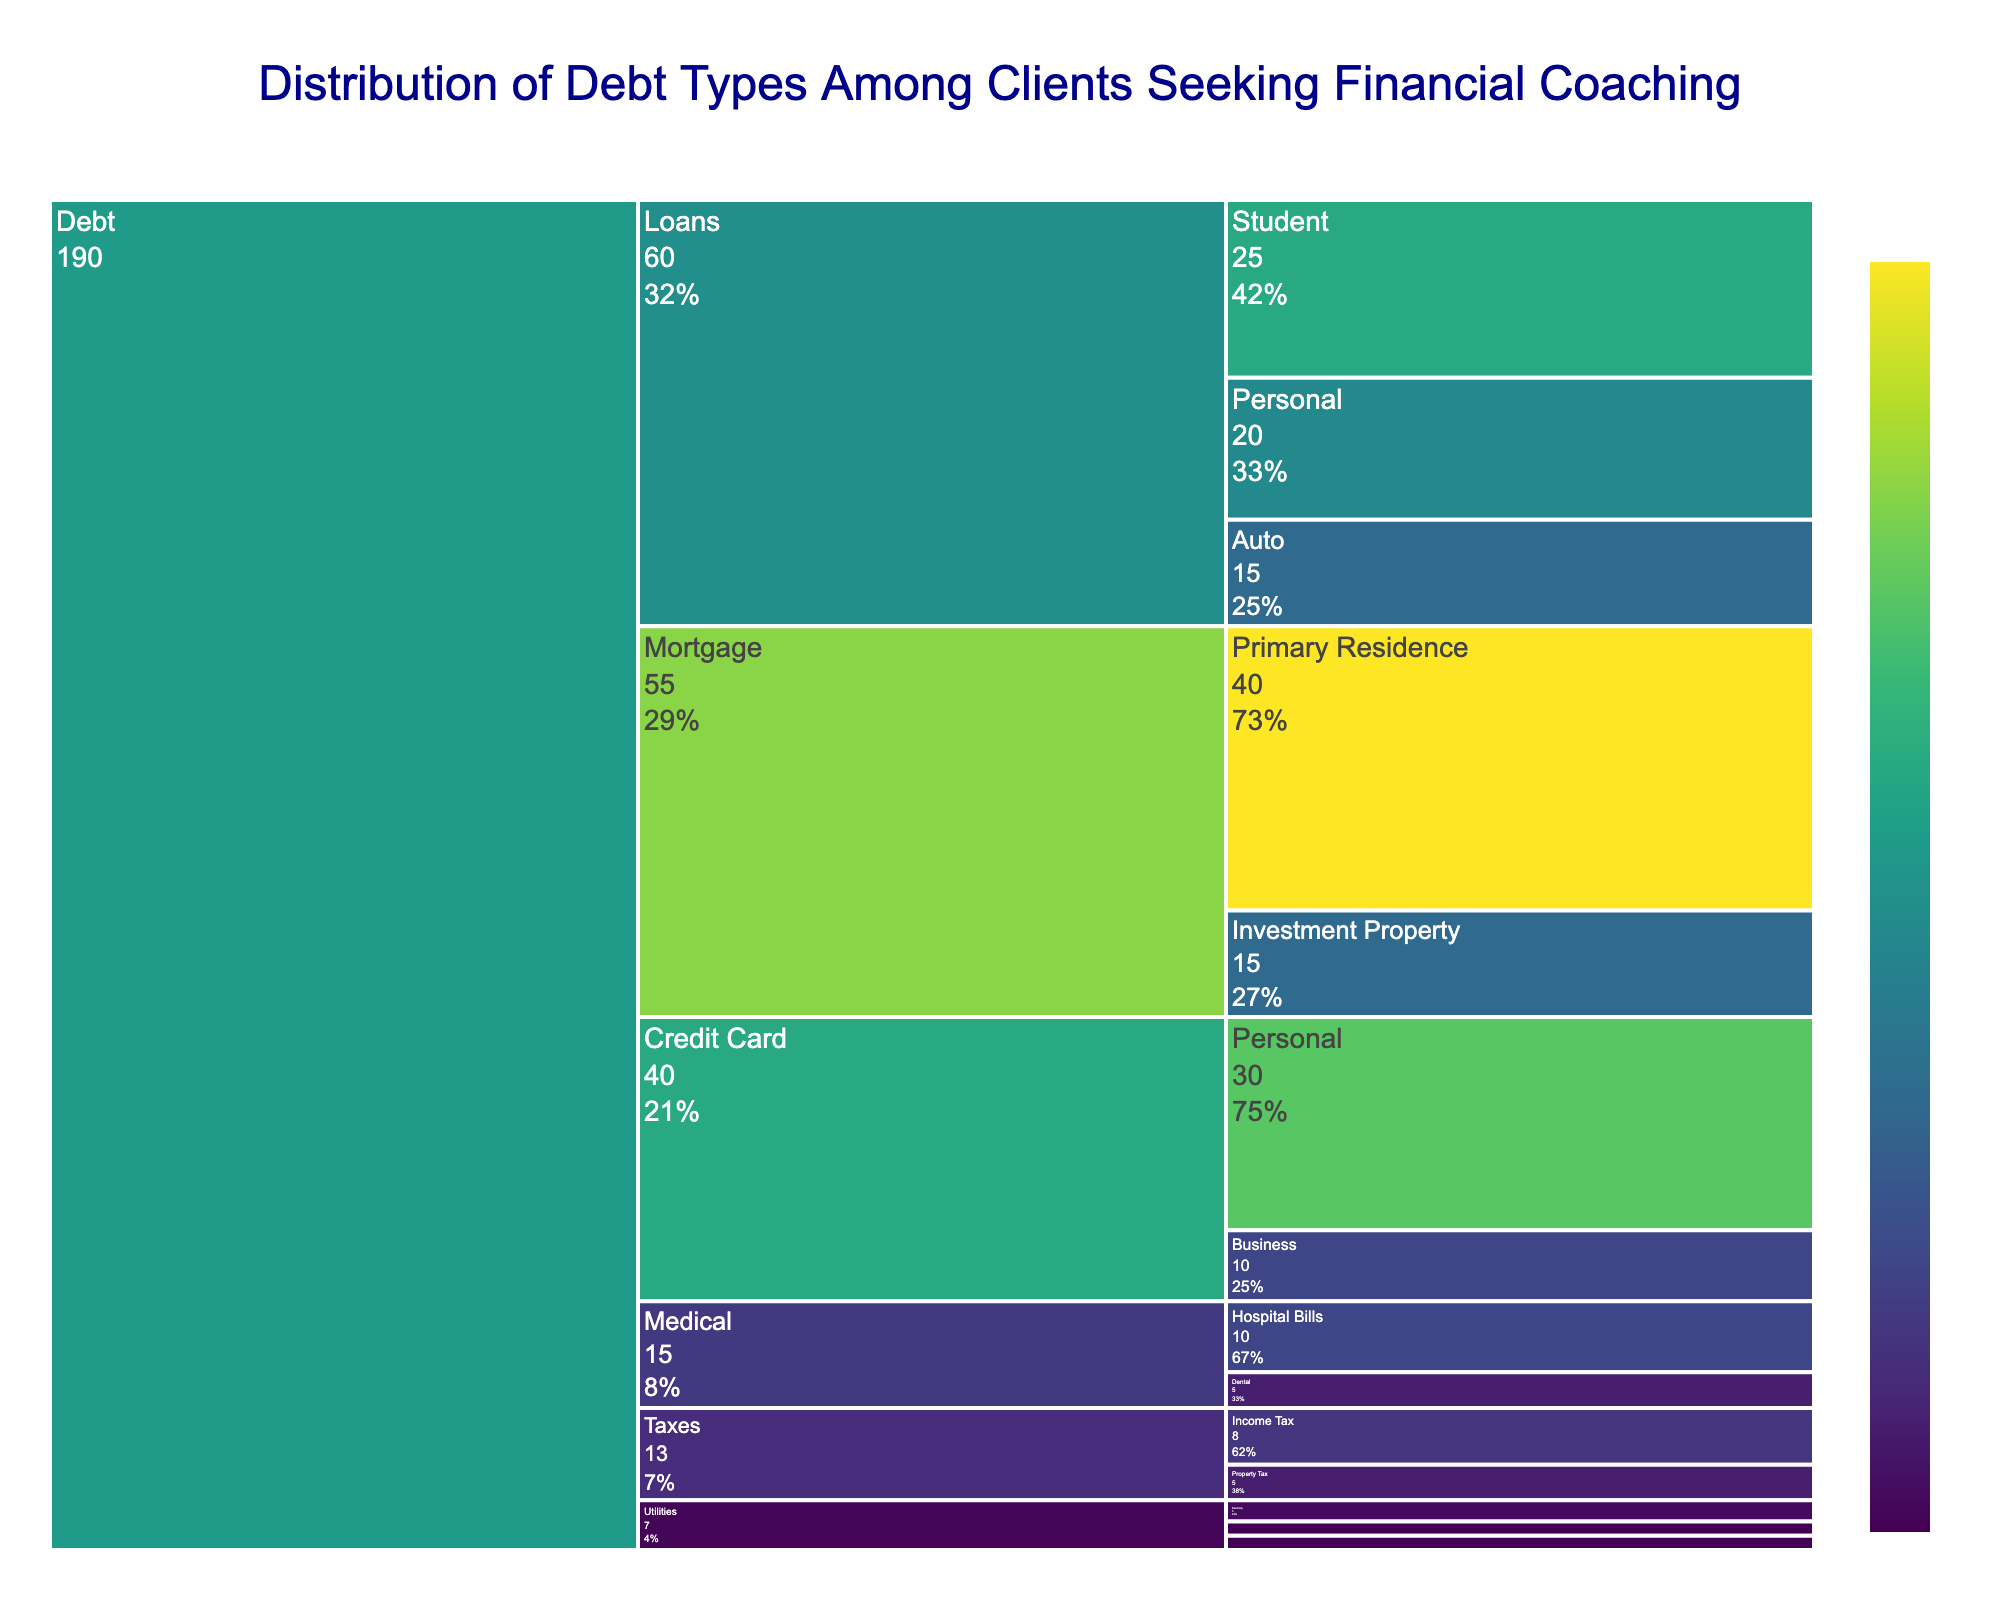What is the title of the icicle chart? The title of the chart is located at the top and usually describes what the chart is about.
Answer: Distribution of Debt Types Among Clients Seeking Financial Coaching Which subtype has the highest value under the 'Mortgage' category? Locate the 'Mortgage' category in the chart, then identify the subtypes under it. Compare their values to find the highest one.
Answer: Primary Residence How much total debt is there under the 'Utilities' category? Identify the 'Utilities' category, then sum the values of all subtypes under it: Electricity (3) + Water (2) + Gas (2).
Answer: 7 Which has a higher value: Student Loans or Business Credit Card? Compare the value of Student Loans (25) under the Loans category and Business Credit Card (10) under the Credit Card category.
Answer: Student Loans What percentage does Personal Credit Card debt contribute to the total Credit Card debt? Divide the value of Personal Credit Card (30) by the total Credit Card debt (Personal 30 + Business 10 = 40) and multiply by 100 to get the percentage.
Answer: 75% What is the combined value of all debt types under the 'Medical' category? Sum the values of Hospital Bills (10) and Dental (5) under the Medical category.
Answer: 15 Which category has the smallest total value of debt? Sum the total values of each category and compare them to find the smallest category. Utilities have Electricity (3) + Water (2) + Gas (2) = 7, which is the smallest compared to other categories.
Answer: Utilities How many subtypes are there under the 'Taxes' category? Count the number of subtypes listed under the Taxes category in the chart.
Answer: 2 What is the value difference between Primary Residence Mortgage debt and Investment Property Mortgage debt? Subtract the value of Investment Property (15) from the value of Primary Residence (40).
Answer: 25 